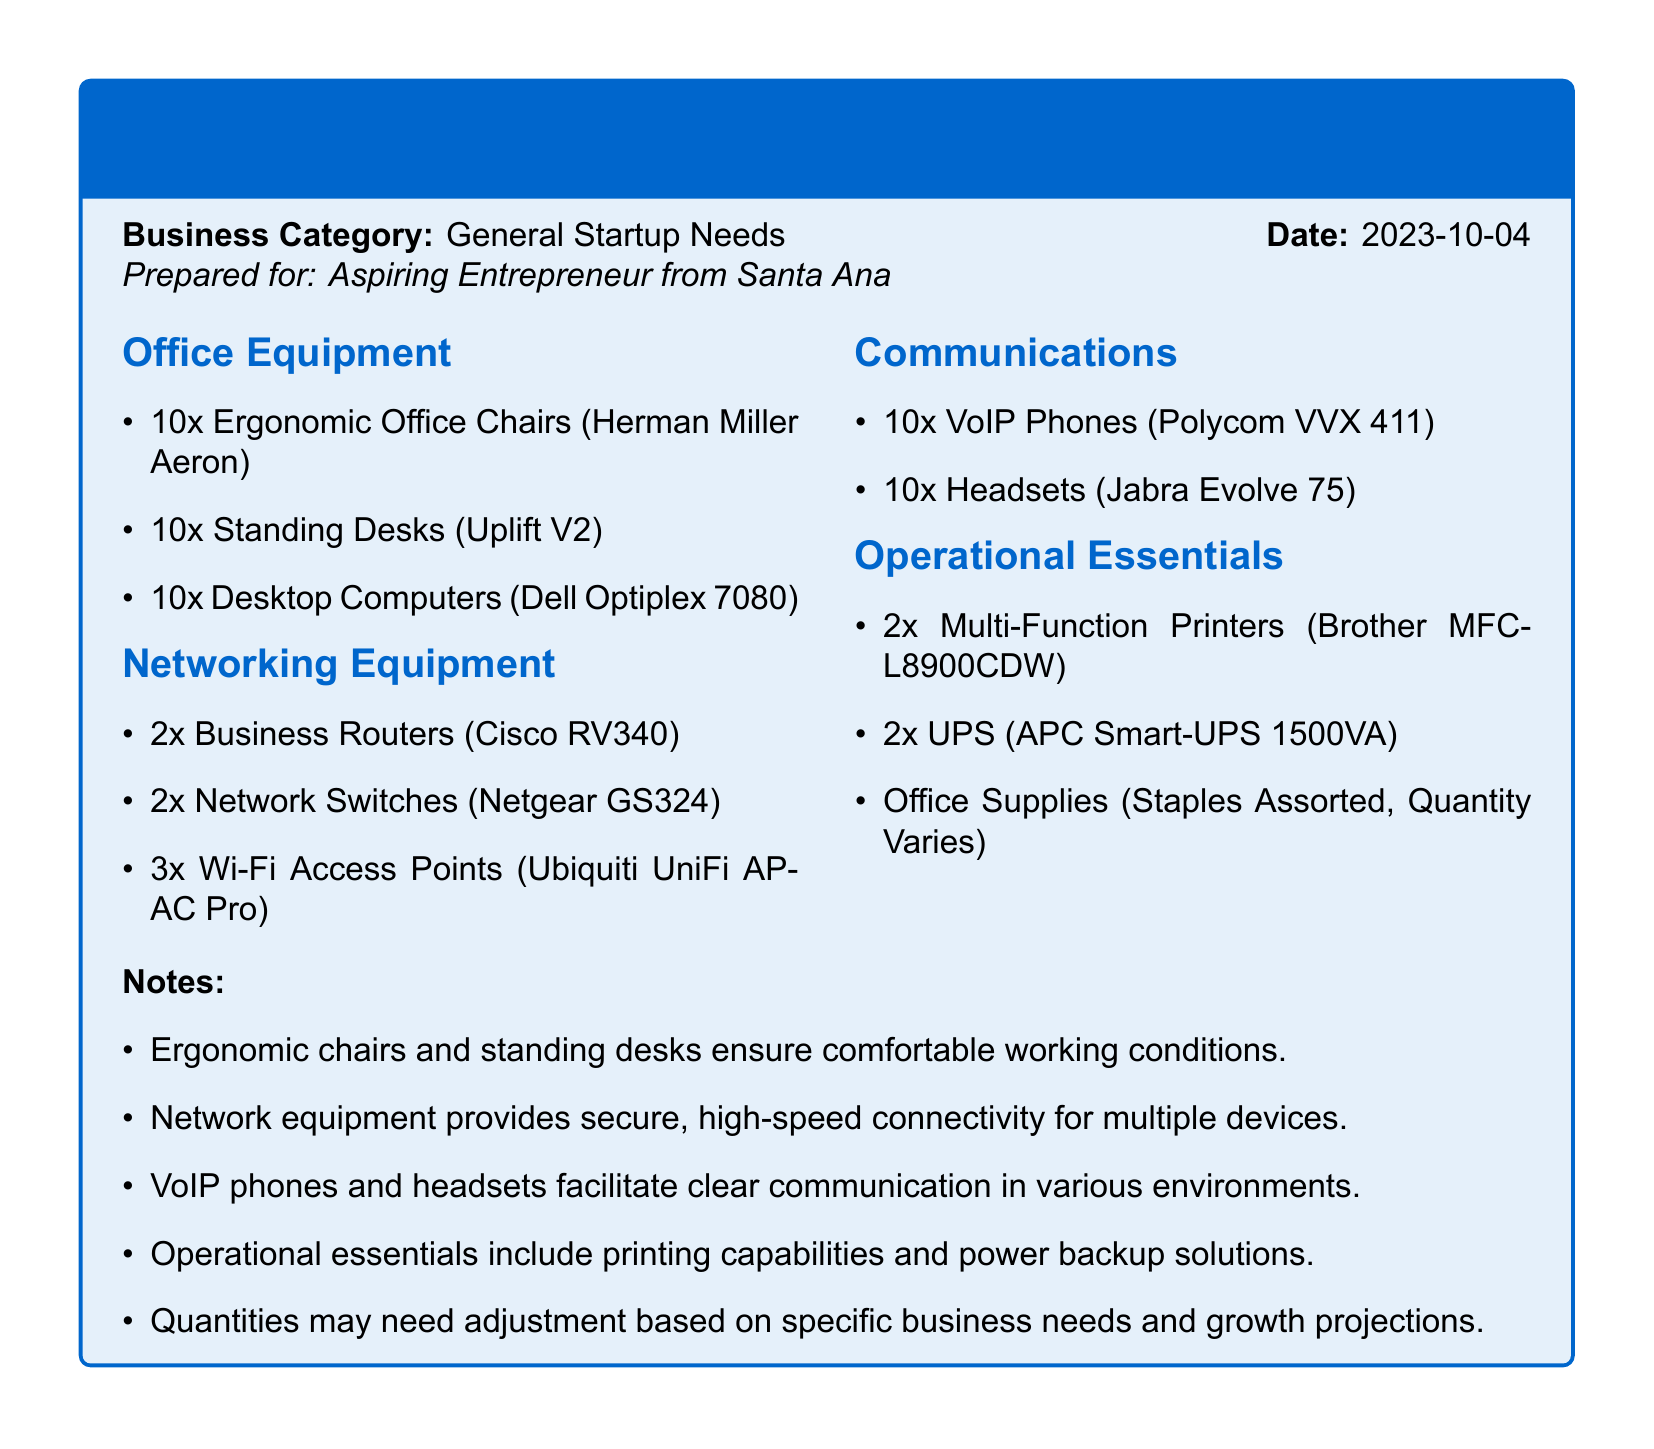what type of document is this? The document is a packing list detailing equipment and hardware needed for operational readiness.
Answer: packing list how many ergonomic office chairs are listed? The packing list specifies the quantity of ergonomic office chairs needed.
Answer: 10 what brand is mentioned for the desktop computers? The packing list specifies the brand of the desktop computers included in the office equipment section.
Answer: Dell how many VoIP phones are required? The number of VoIP phones that need to be acquired is mentioned in the communications section of the list.
Answer: 10 what type of UPS is listed in operational essentials? The document specifies the model of the UPS included in the operational essentials section.
Answer: APC Smart-UPS 1500VA why are ergonomic chairs included in the list? The document explains the purpose of including ergonomic chairs in the office equipment section.
Answer: comfortable working conditions how many multi-function printers are needed? The required number of multi-function printers for operational readiness is noted in the operational essentials section of the packing list.
Answer: 2 what equipment is used for secure connectivity? The packing list identifies specific equipment that provides secure connectivity for multiple devices.
Answer: Business Routers is there a specific note regarding the quantities? The notes section addresses the need for adjustment in quantities based on specific business needs.
Answer: yes 